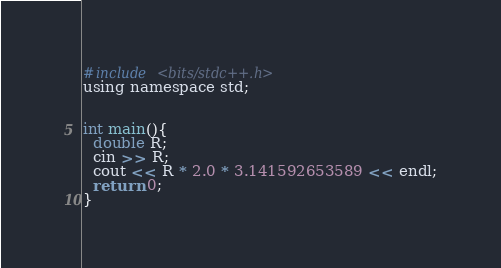<code> <loc_0><loc_0><loc_500><loc_500><_C_>#include <bits/stdc++.h>
using namespace std;


int main(){
  double R;
  cin >> R;
  cout << R * 2.0 * 3.141592653589 << endl;
  return 0;
}
</code> 